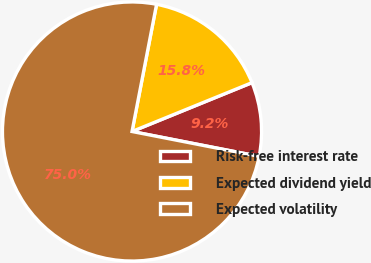<chart> <loc_0><loc_0><loc_500><loc_500><pie_chart><fcel>Risk-free interest rate<fcel>Expected dividend yield<fcel>Expected volatility<nl><fcel>9.23%<fcel>15.81%<fcel>74.96%<nl></chart> 